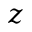Convert formula to latex. <formula><loc_0><loc_0><loc_500><loc_500>z</formula> 